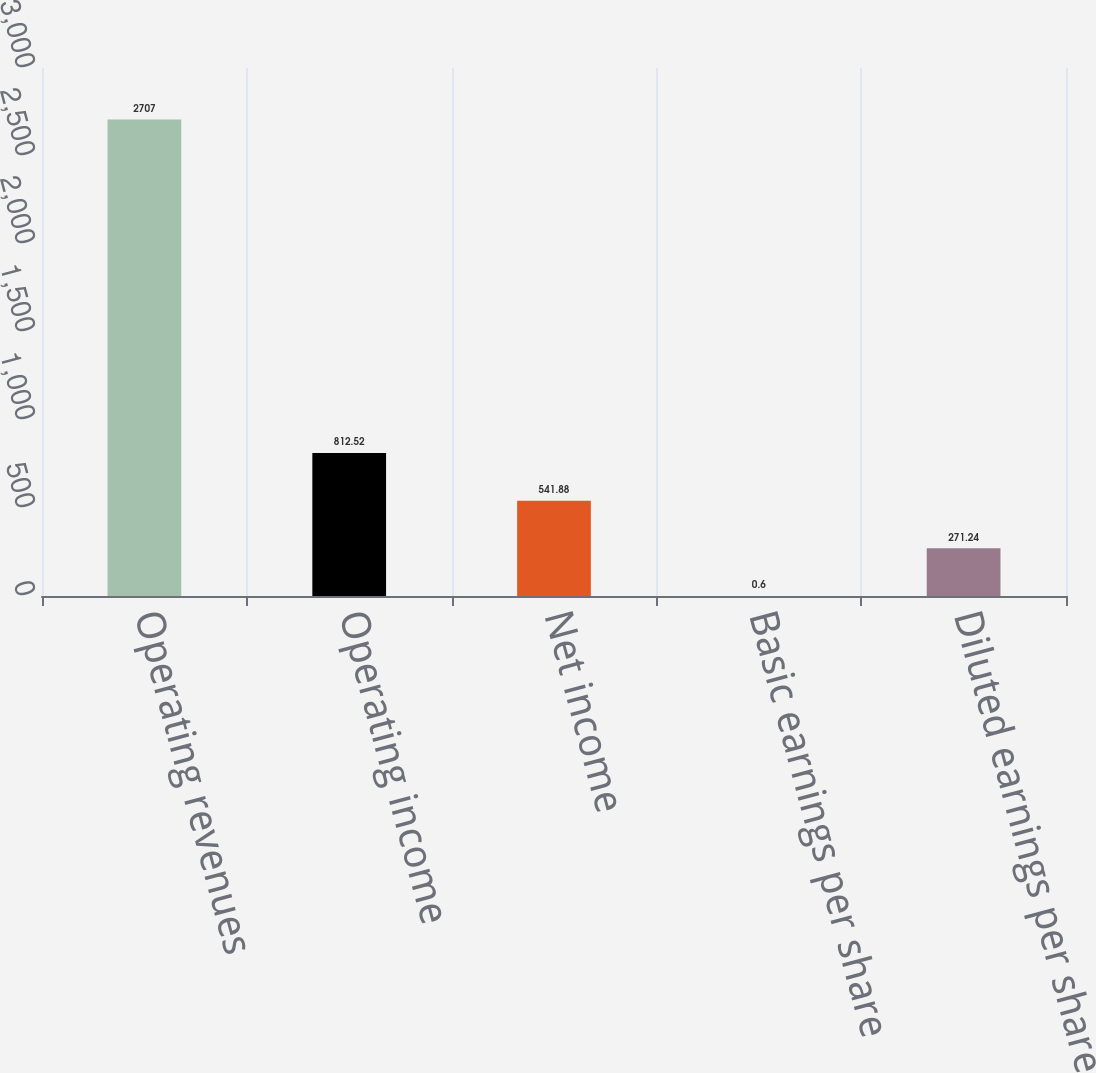Convert chart to OTSL. <chart><loc_0><loc_0><loc_500><loc_500><bar_chart><fcel>Operating revenues<fcel>Operating income<fcel>Net income<fcel>Basic earnings per share<fcel>Diluted earnings per share<nl><fcel>2707<fcel>812.52<fcel>541.88<fcel>0.6<fcel>271.24<nl></chart> 